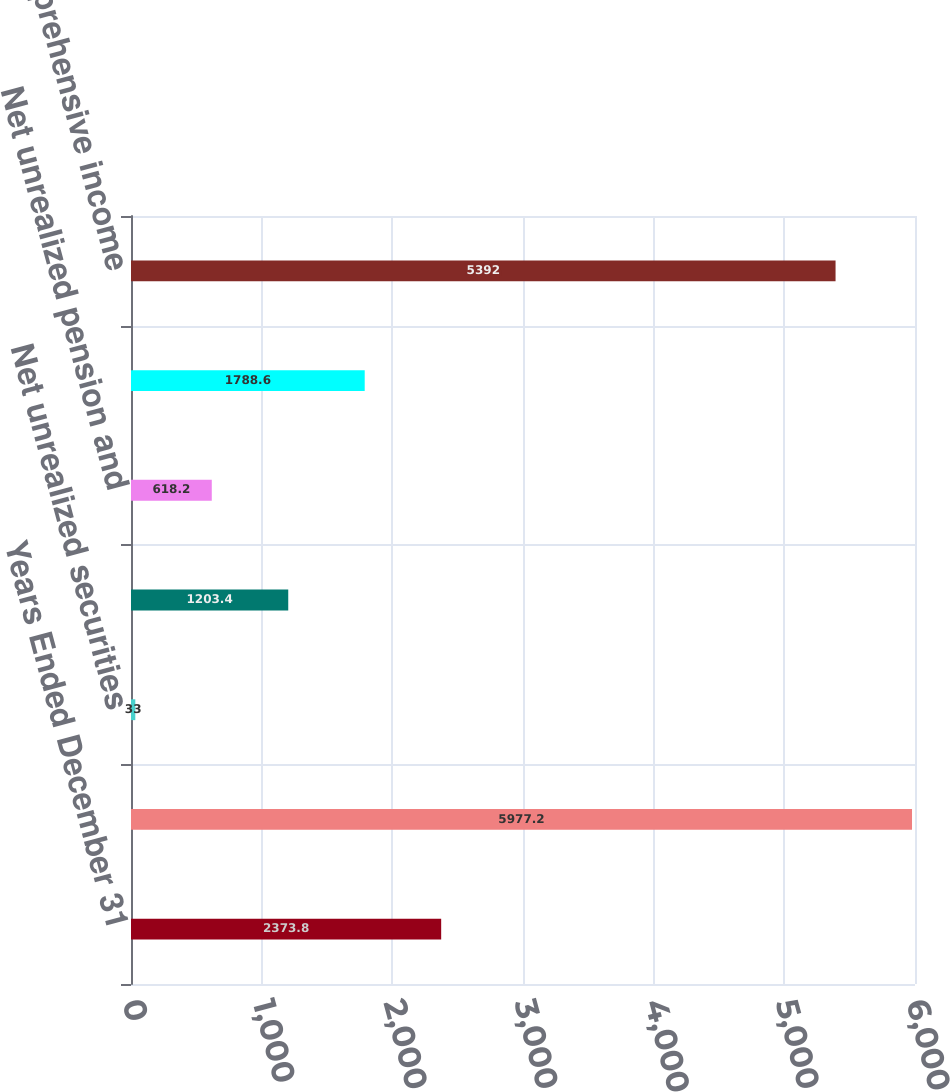<chart> <loc_0><loc_0><loc_500><loc_500><bar_chart><fcel>Years Ended December 31<fcel>Net income<fcel>Net unrealized securities<fcel>Foreign currency translation<fcel>Net unrealized pension and<fcel>Other comprehensive loss<fcel>Comprehensive income<nl><fcel>2373.8<fcel>5977.2<fcel>33<fcel>1203.4<fcel>618.2<fcel>1788.6<fcel>5392<nl></chart> 